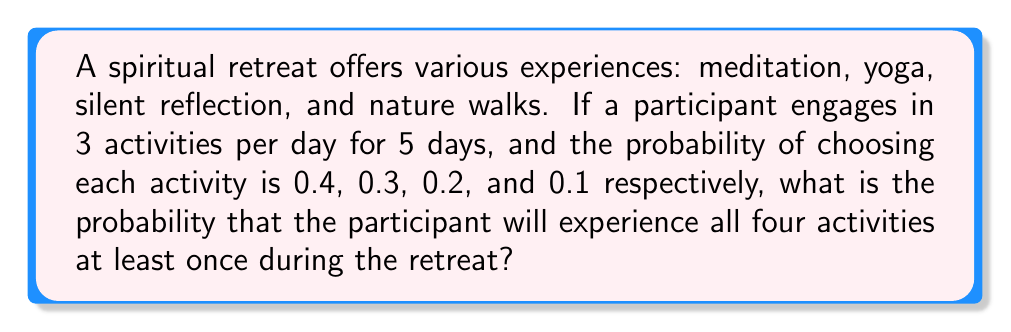Show me your answer to this math problem. Let's approach this step-by-step:

1) First, we need to calculate the probability of not experiencing each activity over the entire retreat.

2) For each activity, the probability of not choosing it in a single selection is:
   Meditation: $1 - 0.4 = 0.6$
   Yoga: $1 - 0.3 = 0.7$
   Silent reflection: $1 - 0.2 = 0.8$
   Nature walks: $1 - 0.1 = 0.9$

3) The total number of activity selections during the retreat is $3 \times 5 = 15$.

4) The probability of not choosing an activity in all 15 selections:
   Meditation: $0.6^{15}$
   Yoga: $0.7^{15}$
   Silent reflection: $0.8^{15}$
   Nature walks: $0.9^{15}$

5) The probability of experiencing all activities at least once is the complement of the probability that at least one activity is not experienced. We can calculate this using the inclusion-exclusion principle:

   $$P(\text{all}) = 1 - (0.6^{15} + 0.7^{15} + 0.8^{15} + 0.9^{15}) + (0.6^{15} \times 0.7^{15} + 0.6^{15} \times 0.8^{15} + 0.6^{15} \times 0.9^{15} + 0.7^{15} \times 0.8^{15} + 0.7^{15} \times 0.9^{15} + 0.8^{15} \times 0.9^{15}) - (0.6^{15} \times 0.7^{15} \times 0.8^{15} + 0.6^{15} \times 0.7^{15} \times 0.9^{15} + 0.6^{15} \times 0.8^{15} \times 0.9^{15} + 0.7^{15} \times 0.8^{15} \times 0.9^{15}) + (0.6^{15} \times 0.7^{15} \times 0.8^{15} \times 0.9^{15})$$

6) Calculating this (you may use a calculator):
   $$P(\text{all}) \approx 0.9999999999999999$$
Answer: $\approx 0.9999999999999999$ 